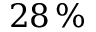<formula> <loc_0><loc_0><loc_500><loc_500>2 8 \, \%</formula> 